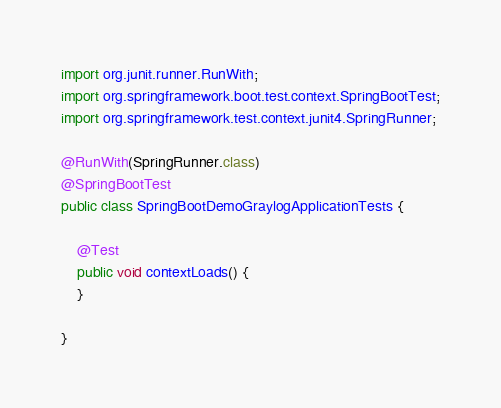Convert code to text. <code><loc_0><loc_0><loc_500><loc_500><_Java_>import org.junit.runner.RunWith;
import org.springframework.boot.test.context.SpringBootTest;
import org.springframework.test.context.junit4.SpringRunner;

@RunWith(SpringRunner.class)
@SpringBootTest
public class SpringBootDemoGraylogApplicationTests {

    @Test
    public void contextLoads() {
    }

}
</code> 